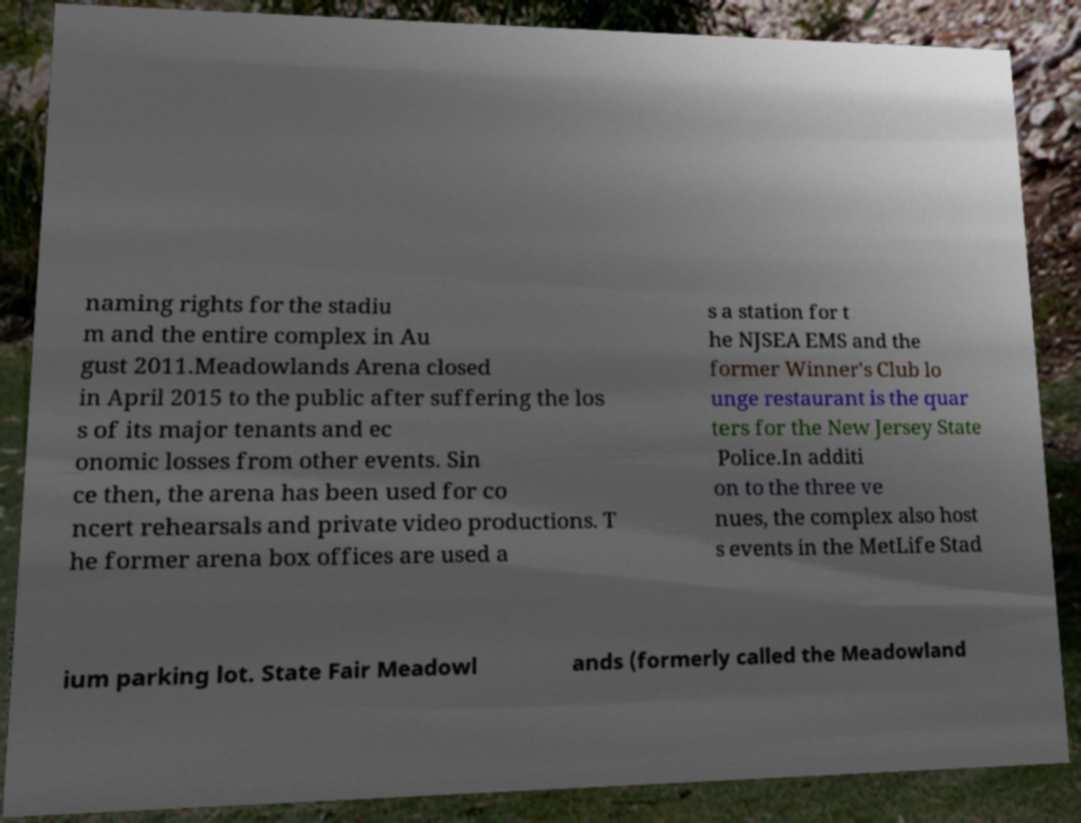What messages or text are displayed in this image? I need them in a readable, typed format. naming rights for the stadiu m and the entire complex in Au gust 2011.Meadowlands Arena closed in April 2015 to the public after suffering the los s of its major tenants and ec onomic losses from other events. Sin ce then, the arena has been used for co ncert rehearsals and private video productions. T he former arena box offices are used a s a station for t he NJSEA EMS and the former Winner's Club lo unge restaurant is the quar ters for the New Jersey State Police.In additi on to the three ve nues, the complex also host s events in the MetLife Stad ium parking lot. State Fair Meadowl ands (formerly called the Meadowland 